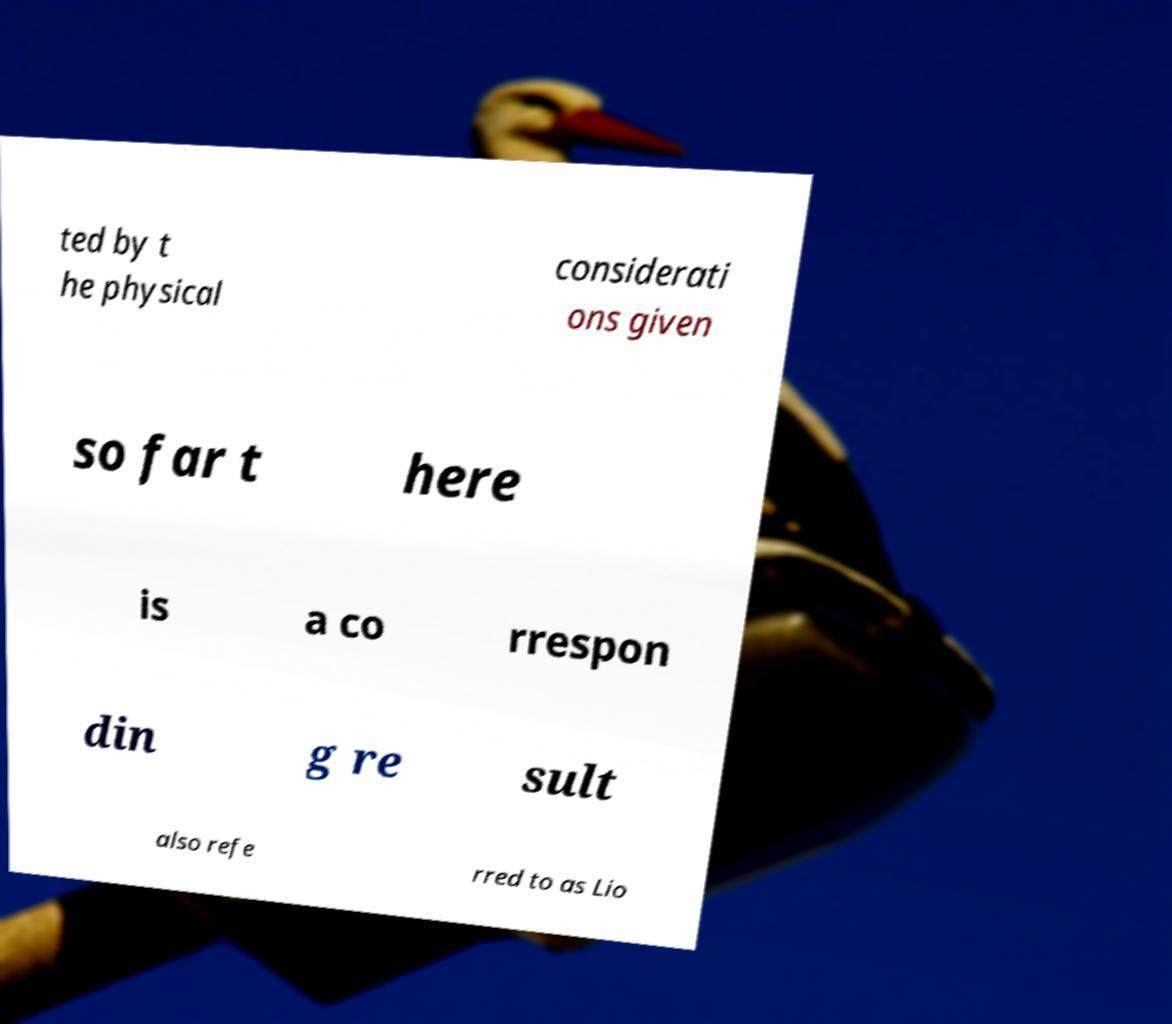Can you read and provide the text displayed in the image?This photo seems to have some interesting text. Can you extract and type it out for me? ted by t he physical considerati ons given so far t here is a co rrespon din g re sult also refe rred to as Lio 